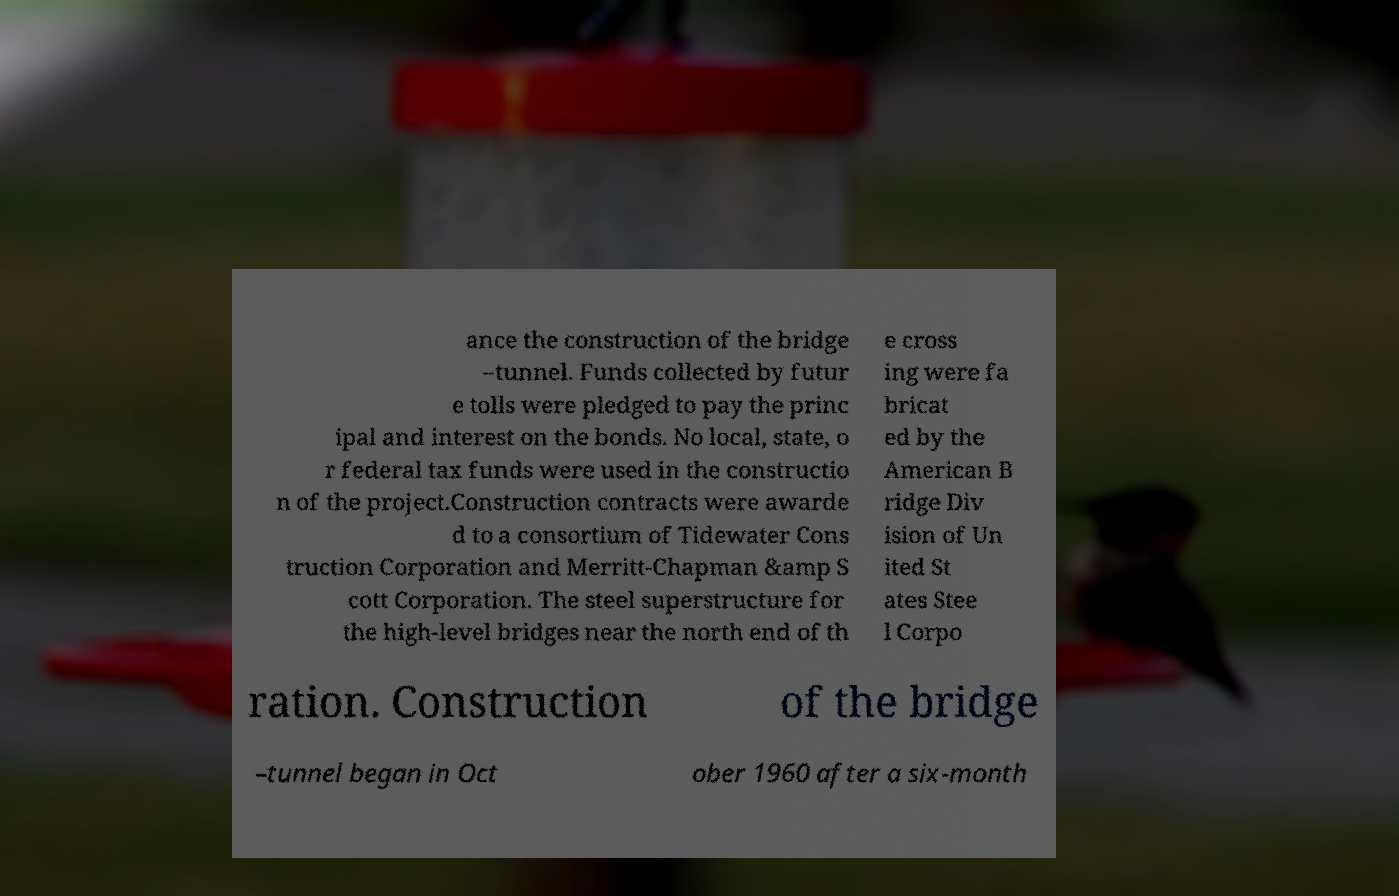What messages or text are displayed in this image? I need them in a readable, typed format. ance the construction of the bridge –tunnel. Funds collected by futur e tolls were pledged to pay the princ ipal and interest on the bonds. No local, state, o r federal tax funds were used in the constructio n of the project.Construction contracts were awarde d to a consortium of Tidewater Cons truction Corporation and Merritt-Chapman &amp S cott Corporation. The steel superstructure for the high-level bridges near the north end of th e cross ing were fa bricat ed by the American B ridge Div ision of Un ited St ates Stee l Corpo ration. Construction of the bridge –tunnel began in Oct ober 1960 after a six-month 